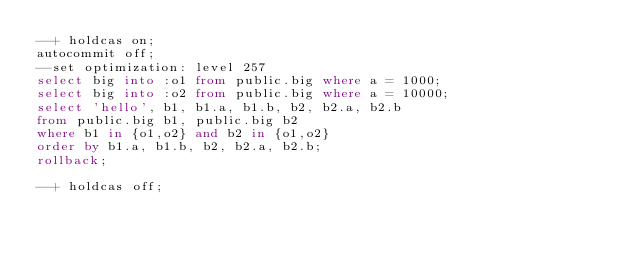Convert code to text. <code><loc_0><loc_0><loc_500><loc_500><_SQL_>--+ holdcas on;
autocommit off;
--set optimization: level 257
select big into :o1 from public.big where a = 1000;
select big into :o2 from public.big where a = 10000;
select 'hello', b1, b1.a, b1.b, b2, b2.a, b2.b
from public.big b1, public.big b2
where b1 in {o1,o2} and b2 in {o1,o2}
order by b1.a, b1.b, b2, b2.a, b2.b;
rollback;

--+ holdcas off;
</code> 